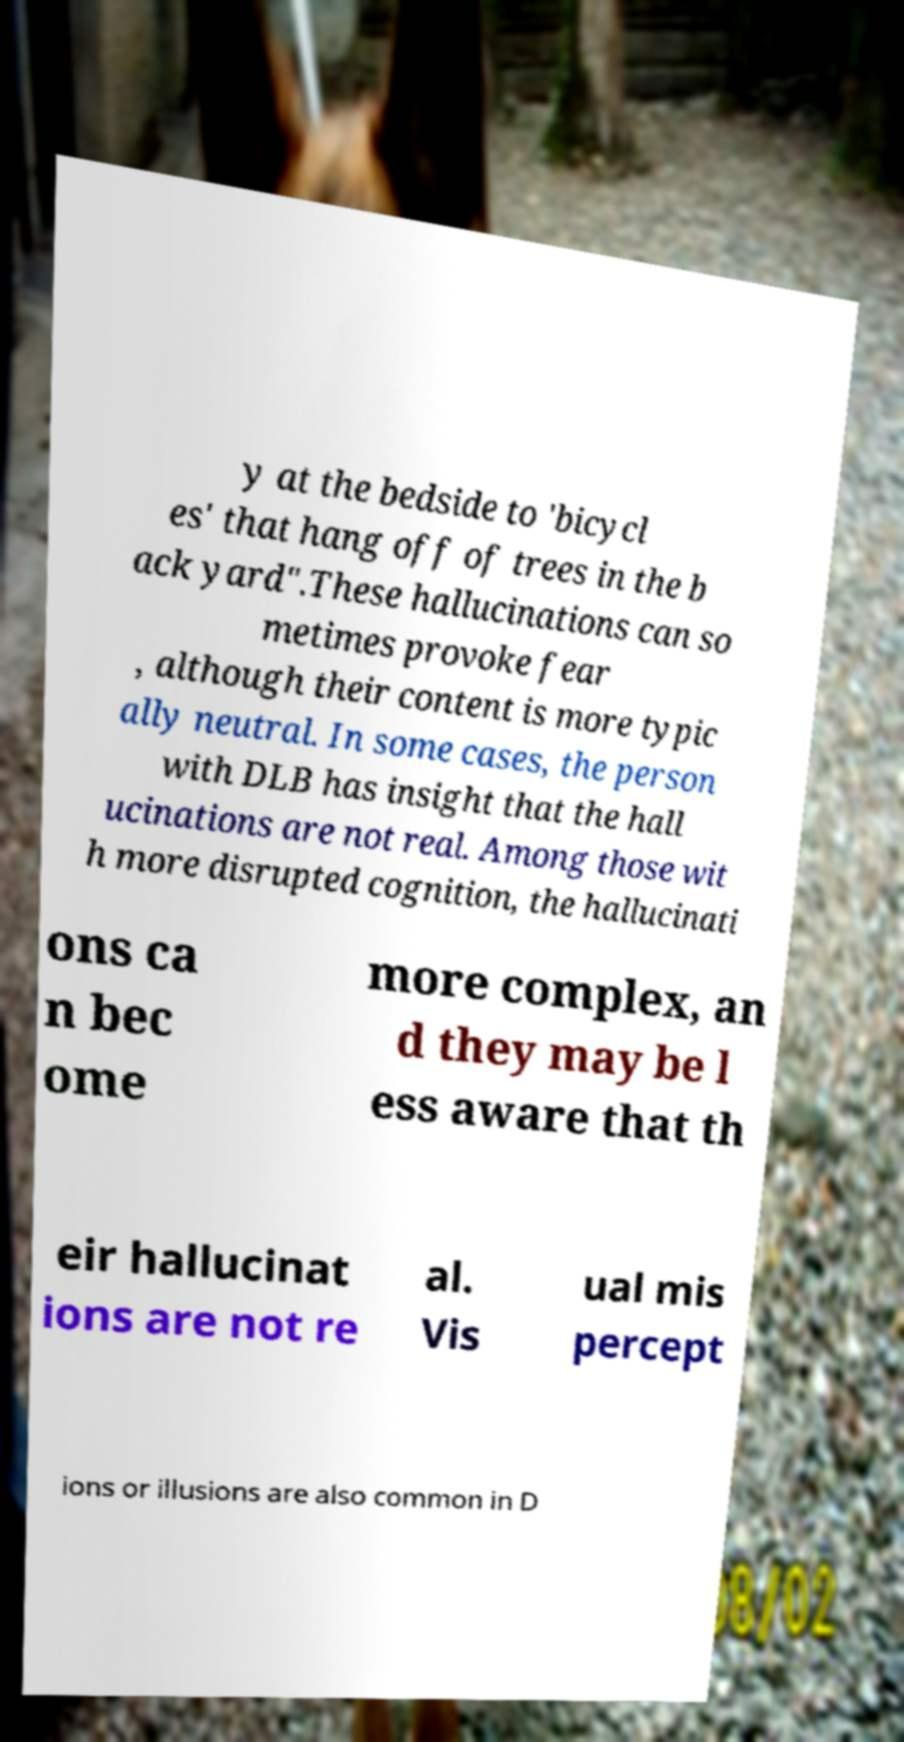Can you accurately transcribe the text from the provided image for me? y at the bedside to 'bicycl es' that hang off of trees in the b ack yard".These hallucinations can so metimes provoke fear , although their content is more typic ally neutral. In some cases, the person with DLB has insight that the hall ucinations are not real. Among those wit h more disrupted cognition, the hallucinati ons ca n bec ome more complex, an d they may be l ess aware that th eir hallucinat ions are not re al. Vis ual mis percept ions or illusions are also common in D 